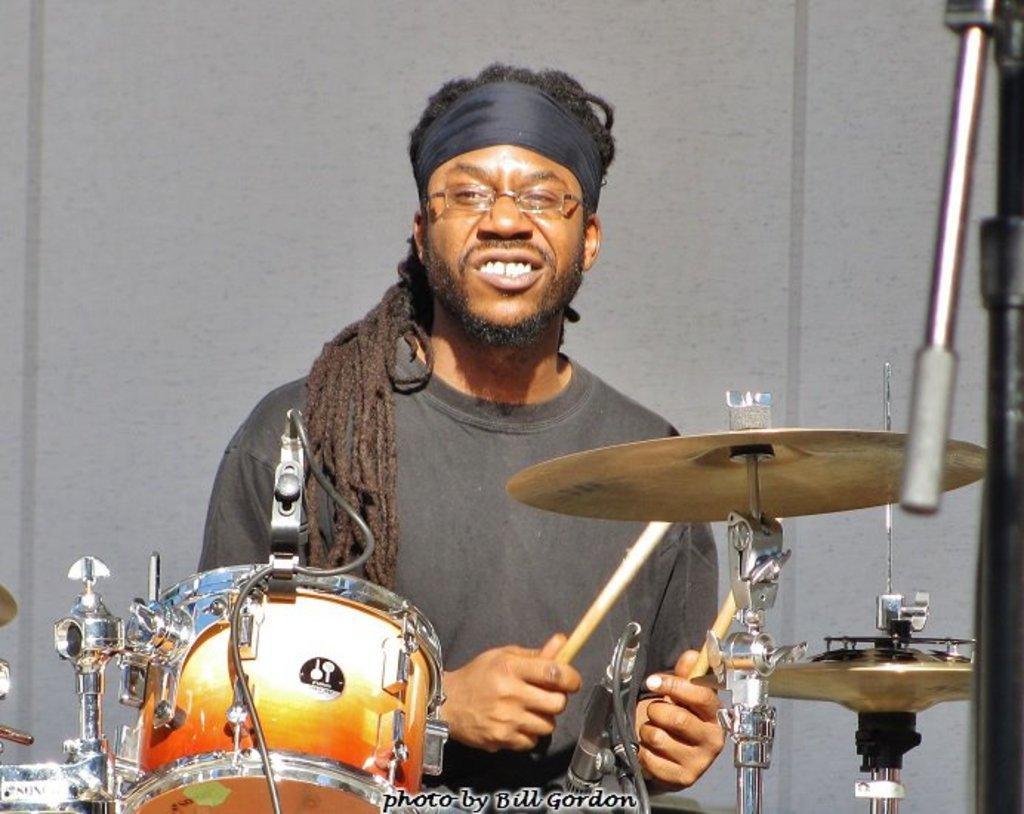Please provide a concise description of this image. In this image there is a man in the center and smiling holding two sticks in hands. In front of the man in the front there is a musical instrument. In the background there is a wall which is white in colour. 